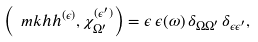Convert formula to latex. <formula><loc_0><loc_0><loc_500><loc_500>\left ( \ m k h h ^ { ( \epsilon ) } , \chi _ { \Omega ^ { \prime } } ^ { ( \epsilon ^ { \prime } ) } \right ) = \epsilon \, \epsilon ( \omega ) \, \delta _ { \Omega \Omega ^ { \prime } } \, \delta _ { \epsilon \epsilon ^ { \prime } } ,</formula> 